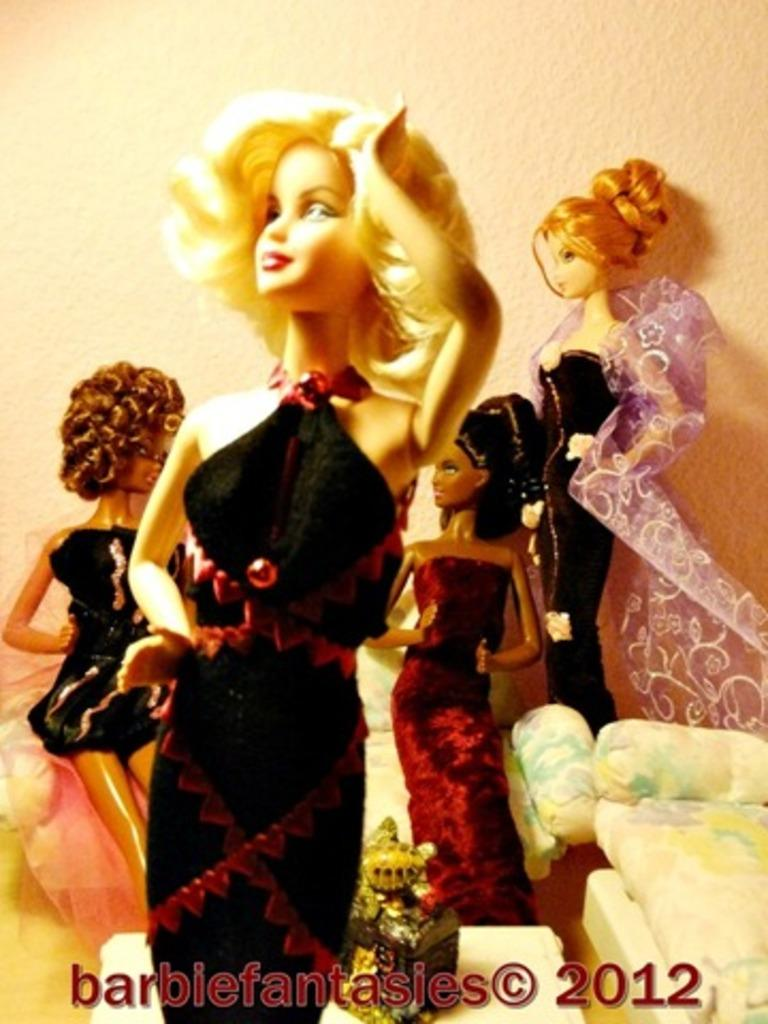What type of toys are present in the image? There are Barbie dolls in the image. Is there any text or logo visible in the image? Yes, there is a watermark in the image. What can be seen in the background of the image? There is a wall in the background of the image. What type of music is being played by the Barbie dolls in the image? There is no indication of music or any sound in the image, as it only features Barbie dolls and a wall in the background. 